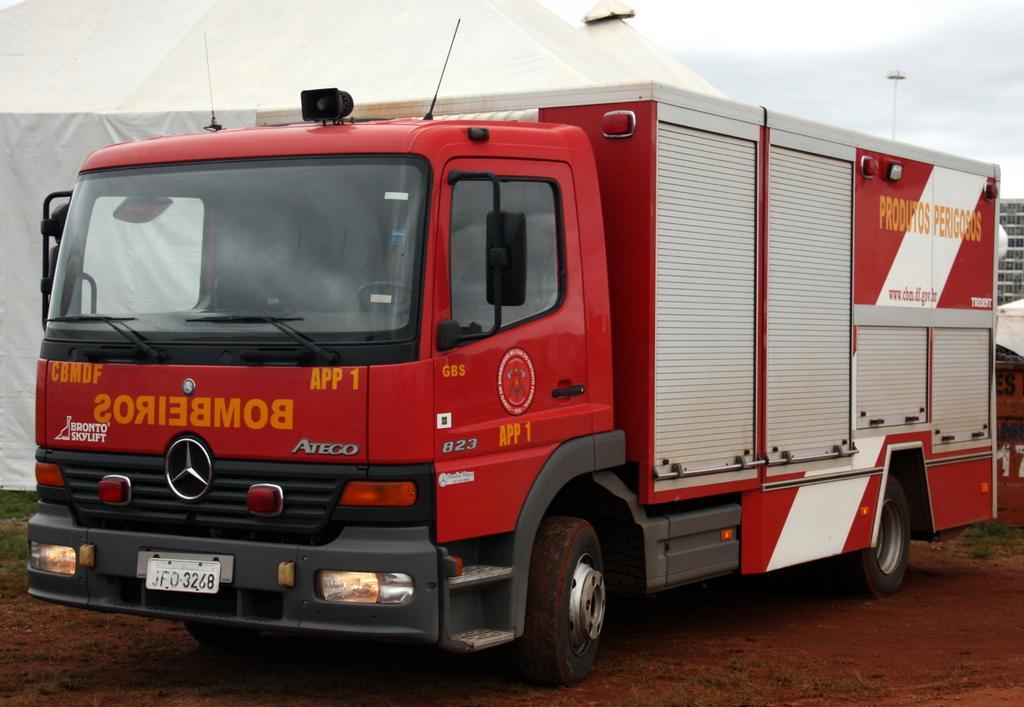In one or two sentences, can you explain what this image depicts? In this image, I can see a truck. Behind the truck, there is a tent. On the right corner of the image, I can see a building. In the background, there is the sky. 